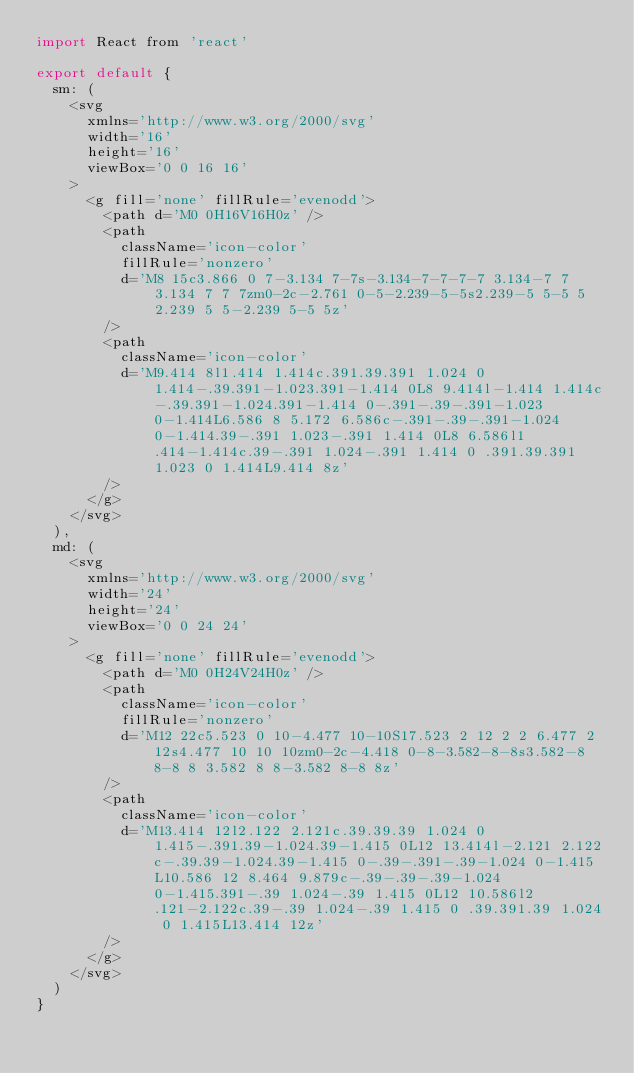Convert code to text. <code><loc_0><loc_0><loc_500><loc_500><_JavaScript_>import React from 'react'

export default {
  sm: (
    <svg
      xmlns='http://www.w3.org/2000/svg'
      width='16'
      height='16'
      viewBox='0 0 16 16'
    >
      <g fill='none' fillRule='evenodd'>
        <path d='M0 0H16V16H0z' />
        <path
          className='icon-color'
          fillRule='nonzero'
          d='M8 15c3.866 0 7-3.134 7-7s-3.134-7-7-7-7 3.134-7 7 3.134 7 7 7zm0-2c-2.761 0-5-2.239-5-5s2.239-5 5-5 5 2.239 5 5-2.239 5-5 5z'
        />
        <path
          className='icon-color'
          d='M9.414 8l1.414 1.414c.391.39.391 1.024 0 1.414-.39.391-1.023.391-1.414 0L8 9.414l-1.414 1.414c-.39.391-1.024.391-1.414 0-.391-.39-.391-1.023 0-1.414L6.586 8 5.172 6.586c-.391-.39-.391-1.024 0-1.414.39-.391 1.023-.391 1.414 0L8 6.586l1.414-1.414c.39-.391 1.024-.391 1.414 0 .391.39.391 1.023 0 1.414L9.414 8z'
        />
      </g>
    </svg>
  ),
  md: (
    <svg
      xmlns='http://www.w3.org/2000/svg'
      width='24'
      height='24'
      viewBox='0 0 24 24'
    >
      <g fill='none' fillRule='evenodd'>
        <path d='M0 0H24V24H0z' />
        <path
          className='icon-color'
          fillRule='nonzero'
          d='M12 22c5.523 0 10-4.477 10-10S17.523 2 12 2 2 6.477 2 12s4.477 10 10 10zm0-2c-4.418 0-8-3.582-8-8s3.582-8 8-8 8 3.582 8 8-3.582 8-8 8z'
        />
        <path
          className='icon-color'
          d='M13.414 12l2.122 2.121c.39.39.39 1.024 0 1.415-.391.39-1.024.39-1.415 0L12 13.414l-2.121 2.122c-.39.39-1.024.39-1.415 0-.39-.391-.39-1.024 0-1.415L10.586 12 8.464 9.879c-.39-.39-.39-1.024 0-1.415.391-.39 1.024-.39 1.415 0L12 10.586l2.121-2.122c.39-.39 1.024-.39 1.415 0 .39.391.39 1.024 0 1.415L13.414 12z'
        />
      </g>
    </svg>
  )
}
</code> 